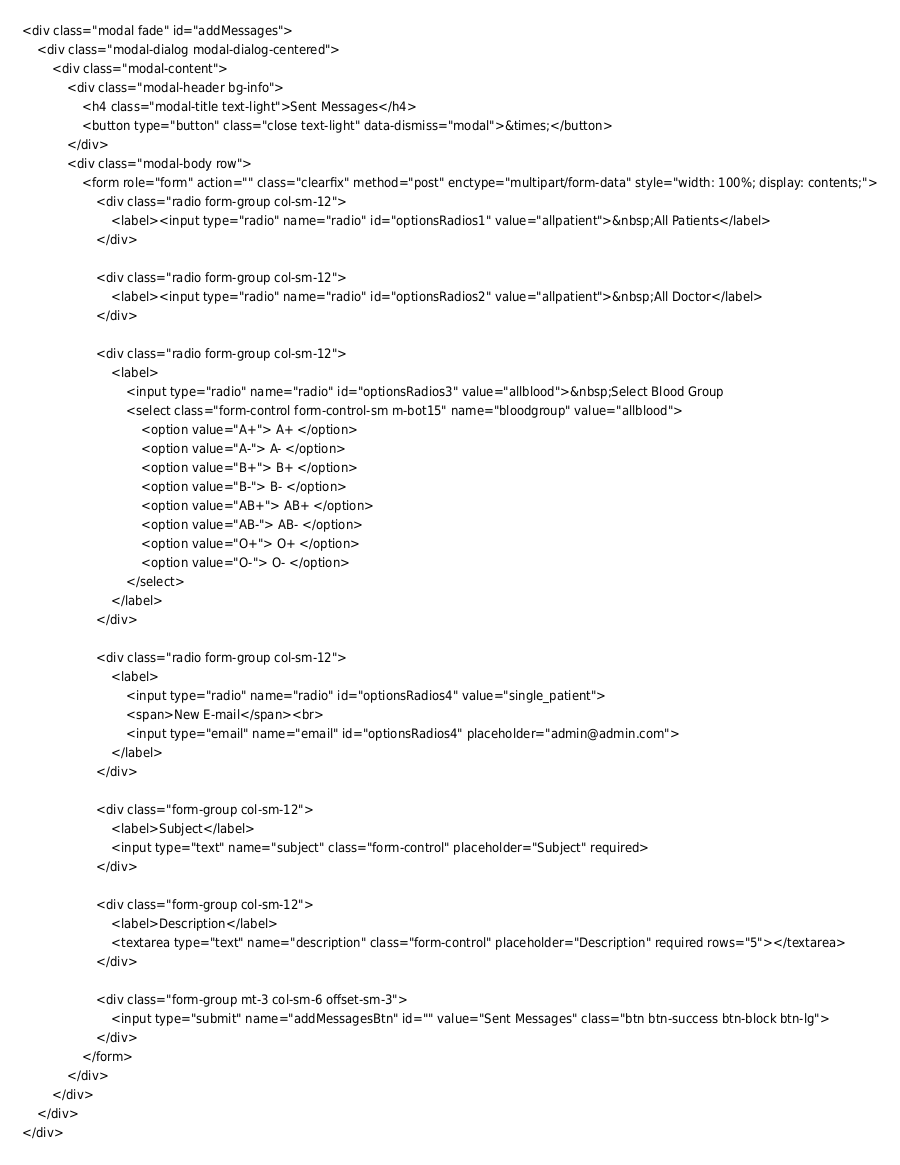<code> <loc_0><loc_0><loc_500><loc_500><_PHP_><div class="modal fade" id="addMessages">
    <div class="modal-dialog modal-dialog-centered">
        <div class="modal-content">
            <div class="modal-header bg-info">
                <h4 class="modal-title text-light">Sent Messages</h4>
                <button type="button" class="close text-light" data-dismiss="modal">&times;</button>
            </div>
            <div class="modal-body row">
                <form role="form" action="" class="clearfix" method="post" enctype="multipart/form-data" style="width: 100%; display: contents;">
                    <div class="radio form-group col-sm-12">
                        <label><input type="radio" name="radio" id="optionsRadios1" value="allpatient">&nbsp;All Patients</label>
                    </div>

                    <div class="radio form-group col-sm-12">
                        <label><input type="radio" name="radio" id="optionsRadios2" value="allpatient">&nbsp;All Doctor</label>
                    </div>

                    <div class="radio form-group col-sm-12">
                        <label>
                            <input type="radio" name="radio" id="optionsRadios3" value="allblood">&nbsp;Select Blood Group
                            <select class="form-control form-control-sm m-bot15" name="bloodgroup" value="allblood">
                                <option value="A+"> A+ </option>
                                <option value="A-"> A- </option>
                                <option value="B+"> B+ </option>
                                <option value="B-"> B- </option>
                                <option value="AB+"> AB+ </option>
                                <option value="AB-"> AB- </option>
                                <option value="O+"> O+ </option>
                                <option value="O-"> O- </option>
                            </select>
                        </label>
                    </div>

                    <div class="radio form-group col-sm-12">
                        <label>
                            <input type="radio" name="radio" id="optionsRadios4" value="single_patient">
                            <span>New E-mail</span><br>
                            <input type="email" name="email" id="optionsRadios4" placeholder="admin@admin.com">
                        </label>
                    </div>

                    <div class="form-group col-sm-12">
                        <label>Subject</label>
                        <input type="text" name="subject" class="form-control" placeholder="Subject" required>
                    </div>

                    <div class="form-group col-sm-12">
                        <label>Description</label>
                        <textarea type="text" name="description" class="form-control" placeholder="Description" required rows="5"></textarea>
                    </div>

                    <div class="form-group mt-3 col-sm-6 offset-sm-3">
                        <input type="submit" name="addMessagesBtn" id="" value="Sent Messages" class="btn btn-success btn-block btn-lg">
                    </div>
                </form>
            </div>
        </div>
    </div>
</div>
</code> 